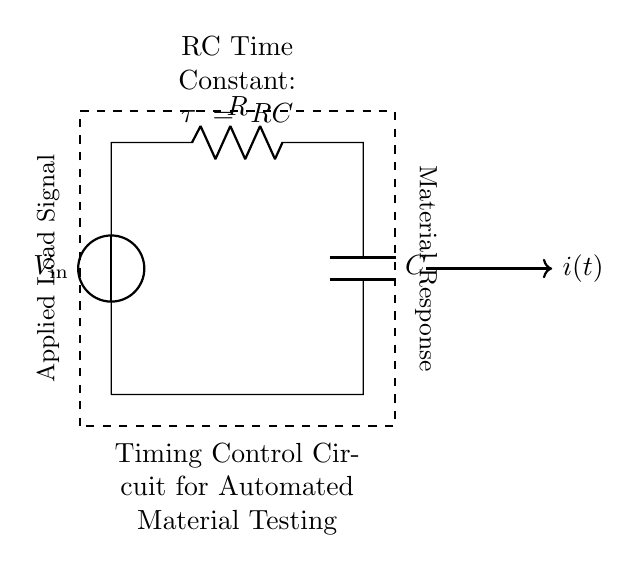What is the voltage source in this circuit? The voltage source is labeled as V_in, which is the component providing electrical potential in the circuit.
Answer: V_in What does the letter "R" represent in the circuit diagram? The letter "R" indicates a resistor, which is a component that limits the flow of electric current.
Answer: Resistor What components are connected in series in this circuit? The components connected in series are the resistor "R" and the capacitor "C", as they are connected end-to-end in the same path.
Answer: Resistor and capacitor What is the time constant formula for this RC circuit? The time constant is represented by the symbol tau (τ) and is calculated using τ = R * C, indicating the time it takes for the capacitor to charge or discharge to about 63.2% of the voltage.
Answer: τ = RC How does increasing the resistance (R) affect the timing control? Increasing the resistance (R) would result in a longer time constant (τ), which means the circuit would take more time to charge or discharge the capacitor.
Answer: Longer timing What is the purpose of the capacitor (C) in this circuit? The capacitor (C) stores and releases electrical energy, and it plays a crucial role in timing applications by controlling the rate of voltage change in the circuit.
Answer: Energy storage What happens to the applied load signal when the capacitor fully charges? When the capacitor is fully charged, the current in the circuit decreases to zero, and the applied load signal stabilizes, reflecting the steady-state condition.
Answer: Current decreases to zero 